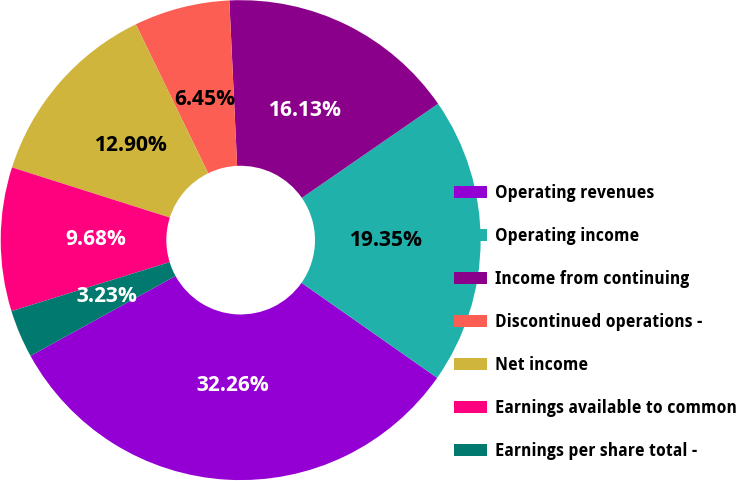Convert chart. <chart><loc_0><loc_0><loc_500><loc_500><pie_chart><fcel>Operating revenues<fcel>Operating income<fcel>Income from continuing<fcel>Discontinued operations -<fcel>Net income<fcel>Earnings available to common<fcel>Earnings per share total -<nl><fcel>32.26%<fcel>19.35%<fcel>16.13%<fcel>6.45%<fcel>12.9%<fcel>9.68%<fcel>3.23%<nl></chart> 